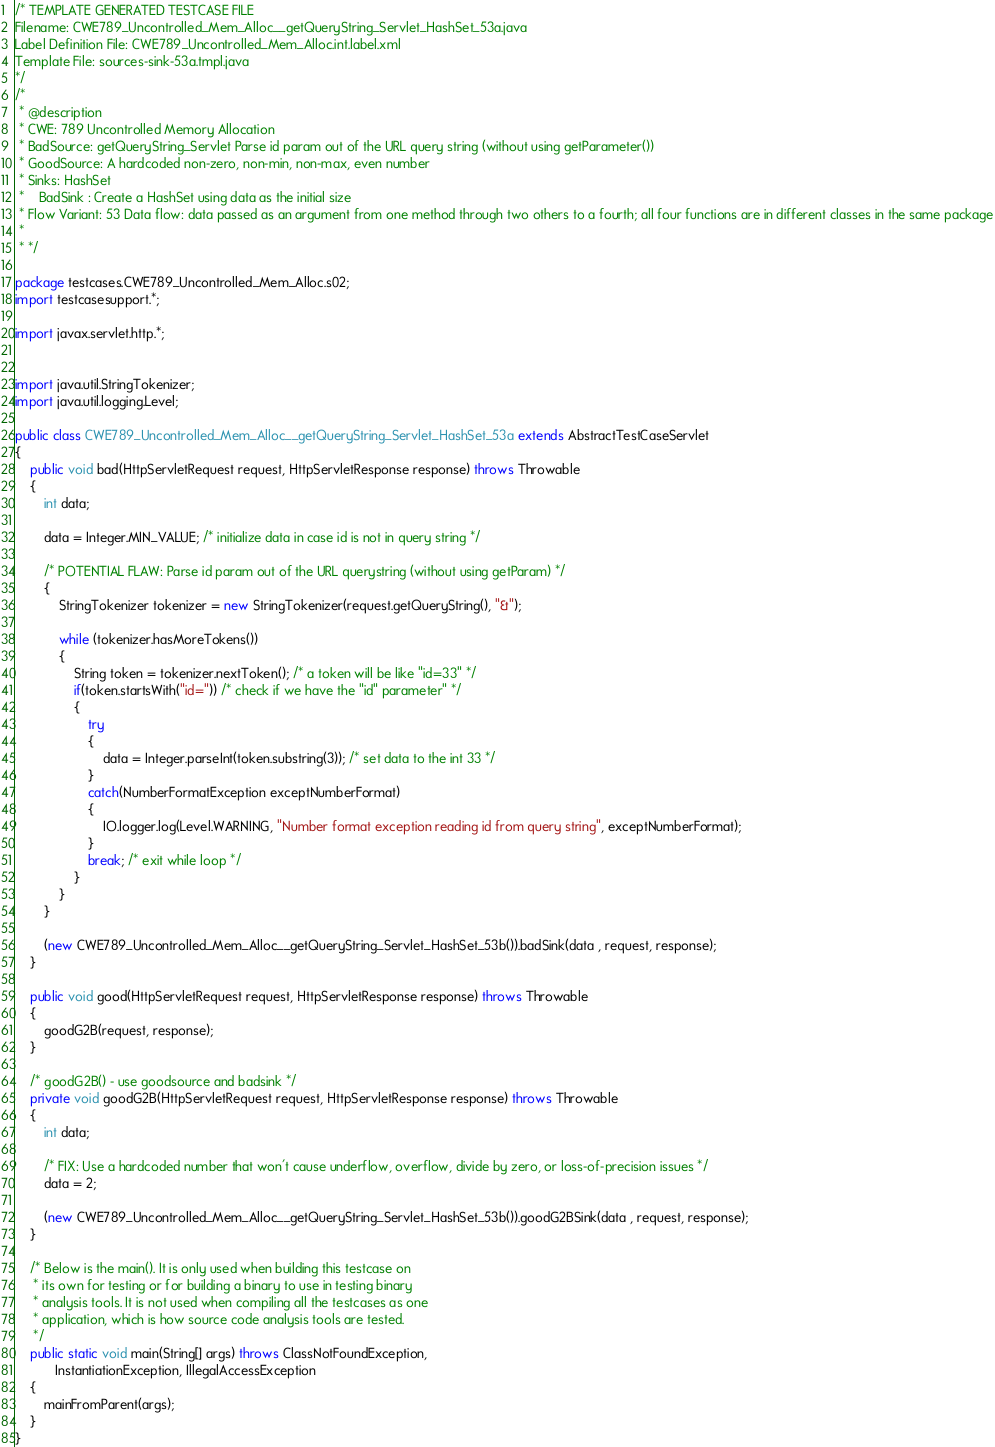<code> <loc_0><loc_0><loc_500><loc_500><_Java_>/* TEMPLATE GENERATED TESTCASE FILE
Filename: CWE789_Uncontrolled_Mem_Alloc__getQueryString_Servlet_HashSet_53a.java
Label Definition File: CWE789_Uncontrolled_Mem_Alloc.int.label.xml
Template File: sources-sink-53a.tmpl.java
*/
/*
 * @description
 * CWE: 789 Uncontrolled Memory Allocation
 * BadSource: getQueryString_Servlet Parse id param out of the URL query string (without using getParameter())
 * GoodSource: A hardcoded non-zero, non-min, non-max, even number
 * Sinks: HashSet
 *    BadSink : Create a HashSet using data as the initial size
 * Flow Variant: 53 Data flow: data passed as an argument from one method through two others to a fourth; all four functions are in different classes in the same package
 *
 * */

package testcases.CWE789_Uncontrolled_Mem_Alloc.s02;
import testcasesupport.*;

import javax.servlet.http.*;


import java.util.StringTokenizer;
import java.util.logging.Level;

public class CWE789_Uncontrolled_Mem_Alloc__getQueryString_Servlet_HashSet_53a extends AbstractTestCaseServlet
{
    public void bad(HttpServletRequest request, HttpServletResponse response) throws Throwable
    {
        int data;

        data = Integer.MIN_VALUE; /* initialize data in case id is not in query string */

        /* POTENTIAL FLAW: Parse id param out of the URL querystring (without using getParam) */
        {
            StringTokenizer tokenizer = new StringTokenizer(request.getQueryString(), "&");

            while (tokenizer.hasMoreTokens())
            {
                String token = tokenizer.nextToken(); /* a token will be like "id=33" */
                if(token.startsWith("id=")) /* check if we have the "id" parameter" */
                {
                    try
                    {
                        data = Integer.parseInt(token.substring(3)); /* set data to the int 33 */
                    }
                    catch(NumberFormatException exceptNumberFormat)
                    {
                        IO.logger.log(Level.WARNING, "Number format exception reading id from query string", exceptNumberFormat);
                    }
                    break; /* exit while loop */
                }
            }
        }

        (new CWE789_Uncontrolled_Mem_Alloc__getQueryString_Servlet_HashSet_53b()).badSink(data , request, response);
    }

    public void good(HttpServletRequest request, HttpServletResponse response) throws Throwable
    {
        goodG2B(request, response);
    }

    /* goodG2B() - use goodsource and badsink */
    private void goodG2B(HttpServletRequest request, HttpServletResponse response) throws Throwable
    {
        int data;

        /* FIX: Use a hardcoded number that won't cause underflow, overflow, divide by zero, or loss-of-precision issues */
        data = 2;

        (new CWE789_Uncontrolled_Mem_Alloc__getQueryString_Servlet_HashSet_53b()).goodG2BSink(data , request, response);
    }

    /* Below is the main(). It is only used when building this testcase on
     * its own for testing or for building a binary to use in testing binary
     * analysis tools. It is not used when compiling all the testcases as one
     * application, which is how source code analysis tools are tested.
     */
    public static void main(String[] args) throws ClassNotFoundException,
           InstantiationException, IllegalAccessException
    {
        mainFromParent(args);
    }
}
</code> 